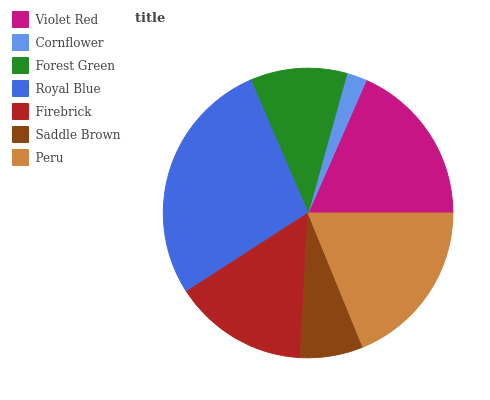Is Cornflower the minimum?
Answer yes or no. Yes. Is Royal Blue the maximum?
Answer yes or no. Yes. Is Forest Green the minimum?
Answer yes or no. No. Is Forest Green the maximum?
Answer yes or no. No. Is Forest Green greater than Cornflower?
Answer yes or no. Yes. Is Cornflower less than Forest Green?
Answer yes or no. Yes. Is Cornflower greater than Forest Green?
Answer yes or no. No. Is Forest Green less than Cornflower?
Answer yes or no. No. Is Firebrick the high median?
Answer yes or no. Yes. Is Firebrick the low median?
Answer yes or no. Yes. Is Saddle Brown the high median?
Answer yes or no. No. Is Cornflower the low median?
Answer yes or no. No. 